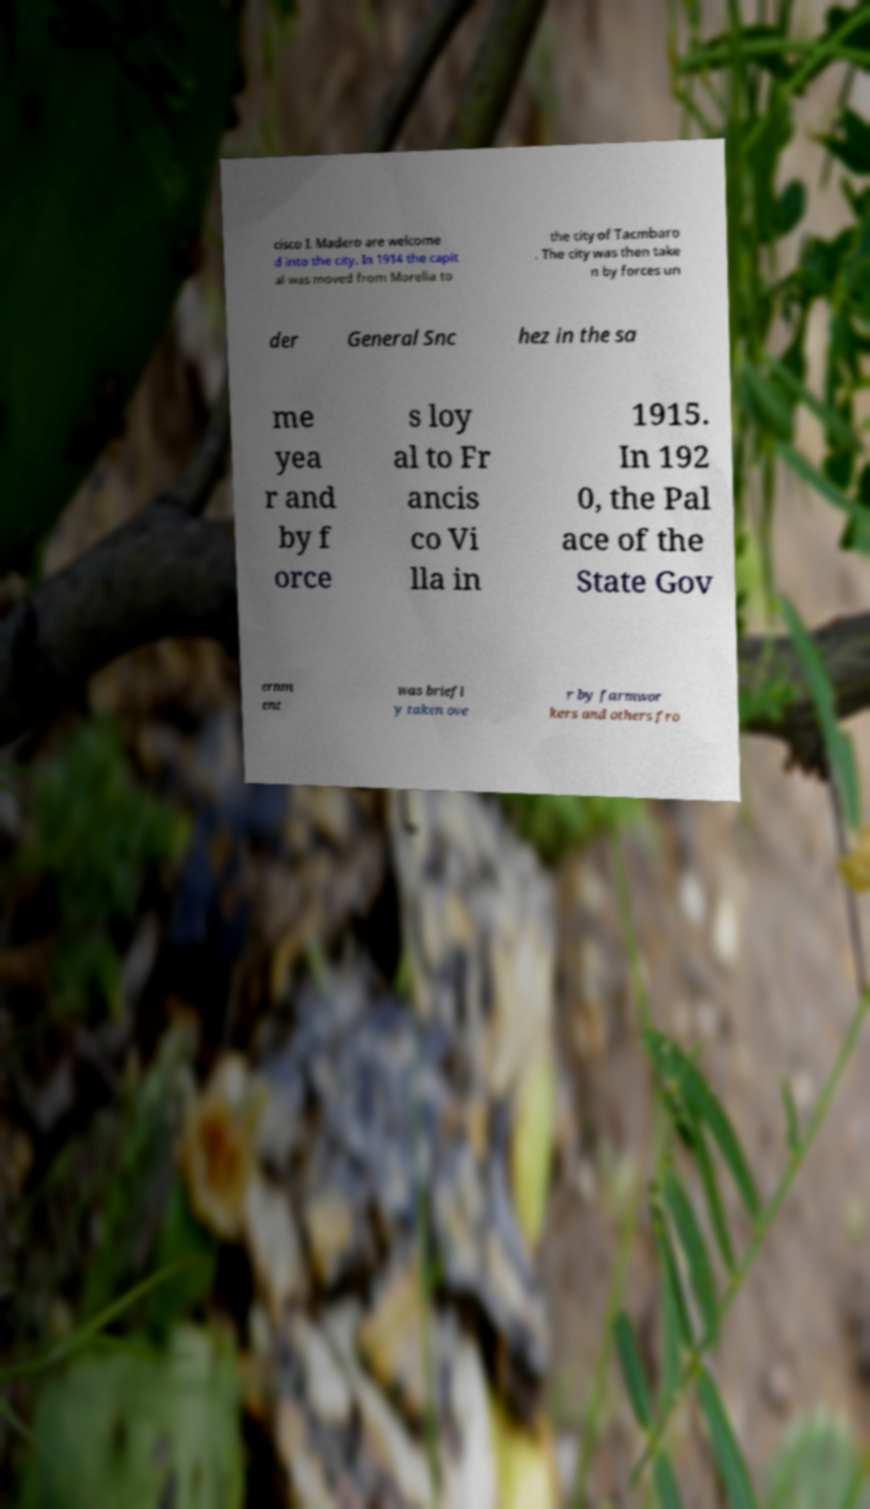For documentation purposes, I need the text within this image transcribed. Could you provide that? cisco I. Madero are welcome d into the city. In 1914 the capit al was moved from Morelia to the city of Tacmbaro . The city was then take n by forces un der General Snc hez in the sa me yea r and by f orce s loy al to Fr ancis co Vi lla in 1915. In 192 0, the Pal ace of the State Gov ernm ent was briefl y taken ove r by farmwor kers and others fro 